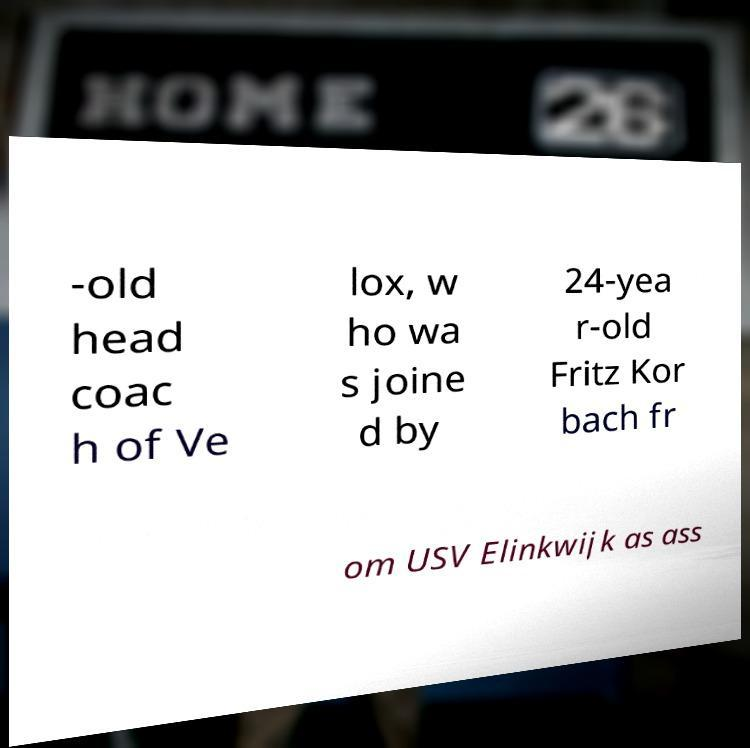There's text embedded in this image that I need extracted. Can you transcribe it verbatim? -old head coac h of Ve lox, w ho wa s joine d by 24-yea r-old Fritz Kor bach fr om USV Elinkwijk as ass 